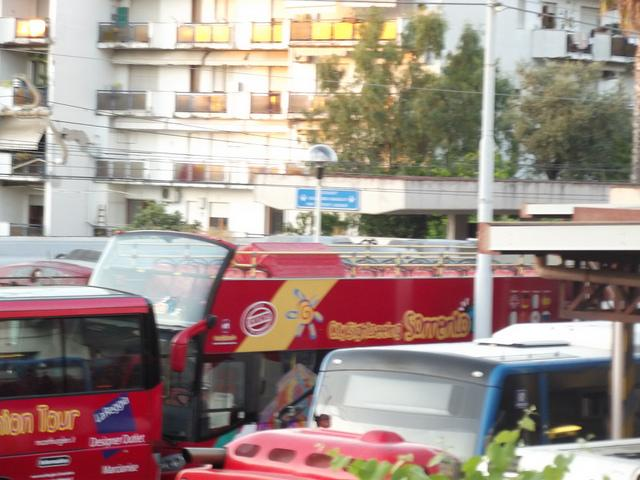What would someone be riding on top of the red bus for? sightseeing 